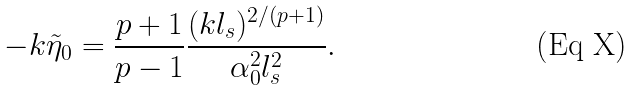<formula> <loc_0><loc_0><loc_500><loc_500>- k \tilde { \eta } _ { 0 } = \frac { p + 1 } { p - 1 } \frac { ( k l _ { s } ) ^ { 2 / ( p + 1 ) } } { \alpha _ { 0 } ^ { 2 } l _ { s } ^ { 2 } } .</formula> 